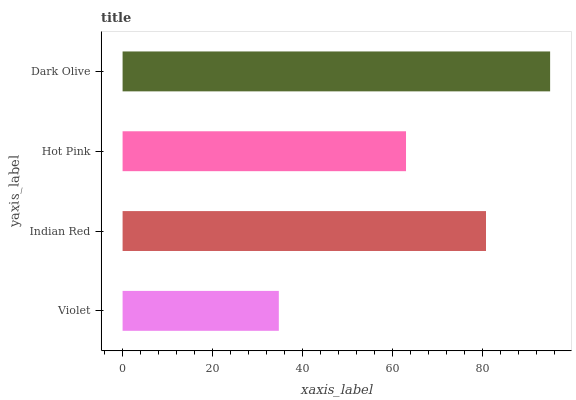Is Violet the minimum?
Answer yes or no. Yes. Is Dark Olive the maximum?
Answer yes or no. Yes. Is Indian Red the minimum?
Answer yes or no. No. Is Indian Red the maximum?
Answer yes or no. No. Is Indian Red greater than Violet?
Answer yes or no. Yes. Is Violet less than Indian Red?
Answer yes or no. Yes. Is Violet greater than Indian Red?
Answer yes or no. No. Is Indian Red less than Violet?
Answer yes or no. No. Is Indian Red the high median?
Answer yes or no. Yes. Is Hot Pink the low median?
Answer yes or no. Yes. Is Violet the high median?
Answer yes or no. No. Is Violet the low median?
Answer yes or no. No. 